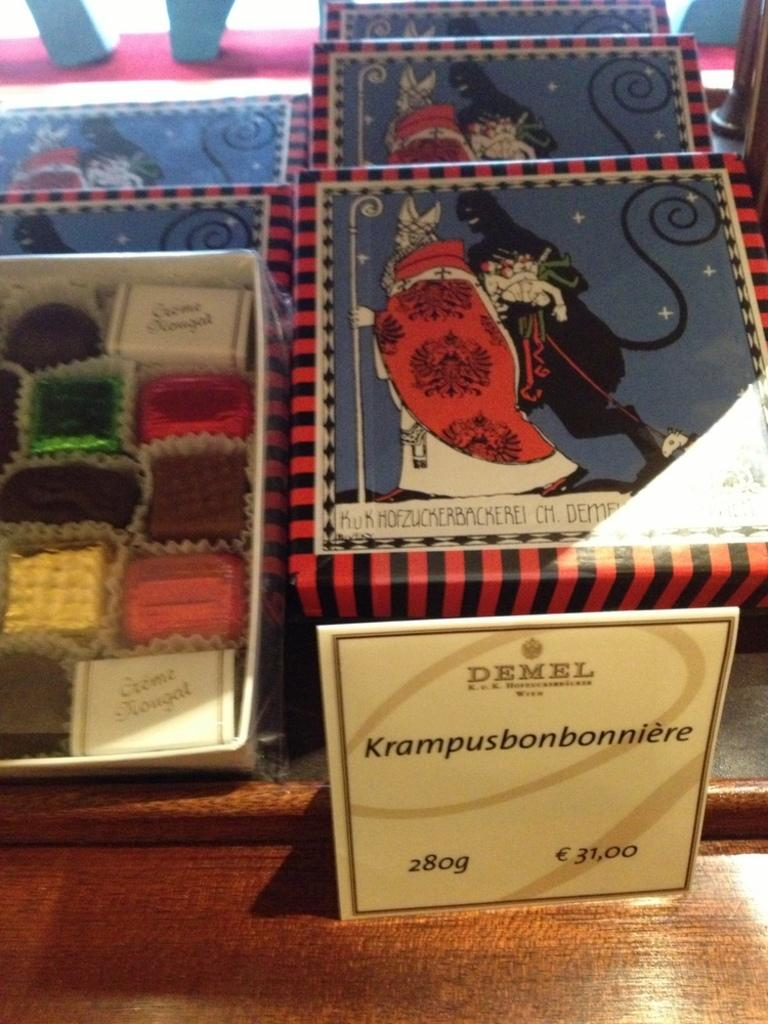<image>
Give a short and clear explanation of the subsequent image. Holiday boxes full of Demel brand chocolates in individual wrappers. 